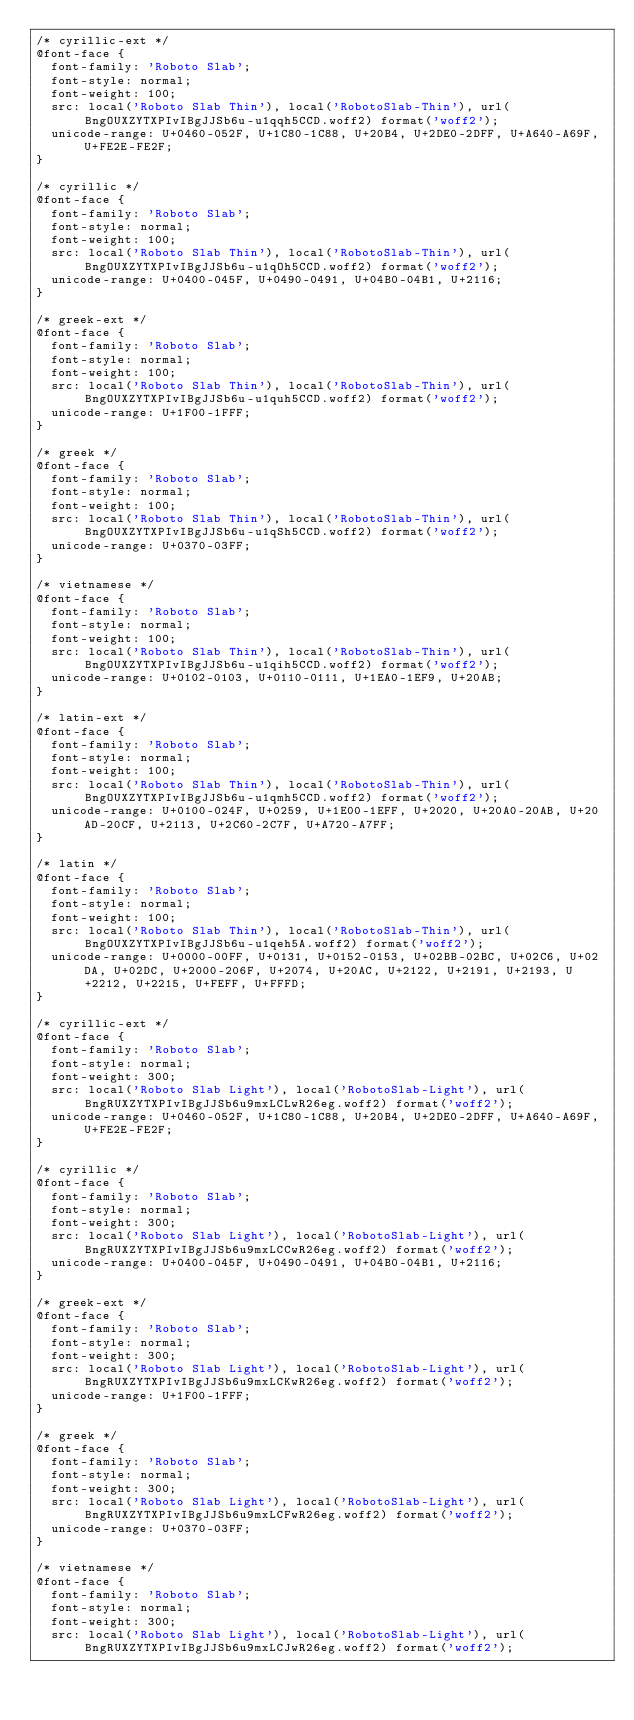Convert code to text. <code><loc_0><loc_0><loc_500><loc_500><_CSS_>/* cyrillic-ext */
@font-face {
	font-family: 'Roboto Slab';
	font-style: normal;
	font-weight: 100;
	src: local('Roboto Slab Thin'), local('RobotoSlab-Thin'), url(BngOUXZYTXPIvIBgJJSb6u-u1qqh5CCD.woff2) format('woff2');
	unicode-range: U+0460-052F, U+1C80-1C88, U+20B4, U+2DE0-2DFF, U+A640-A69F, U+FE2E-FE2F;
}

/* cyrillic */
@font-face {
	font-family: 'Roboto Slab';
	font-style: normal;
	font-weight: 100;
	src: local('Roboto Slab Thin'), local('RobotoSlab-Thin'), url(BngOUXZYTXPIvIBgJJSb6u-u1qOh5CCD.woff2) format('woff2');
	unicode-range: U+0400-045F, U+0490-0491, U+04B0-04B1, U+2116;
}

/* greek-ext */
@font-face {
	font-family: 'Roboto Slab';
	font-style: normal;
	font-weight: 100;
	src: local('Roboto Slab Thin'), local('RobotoSlab-Thin'), url(BngOUXZYTXPIvIBgJJSb6u-u1quh5CCD.woff2) format('woff2');
	unicode-range: U+1F00-1FFF;
}

/* greek */
@font-face {
	font-family: 'Roboto Slab';
	font-style: normal;
	font-weight: 100;
	src: local('Roboto Slab Thin'), local('RobotoSlab-Thin'), url(BngOUXZYTXPIvIBgJJSb6u-u1qSh5CCD.woff2) format('woff2');
	unicode-range: U+0370-03FF;
}

/* vietnamese */
@font-face {
	font-family: 'Roboto Slab';
	font-style: normal;
	font-weight: 100;
	src: local('Roboto Slab Thin'), local('RobotoSlab-Thin'), url(BngOUXZYTXPIvIBgJJSb6u-u1qih5CCD.woff2) format('woff2');
	unicode-range: U+0102-0103, U+0110-0111, U+1EA0-1EF9, U+20AB;
}

/* latin-ext */
@font-face {
	font-family: 'Roboto Slab';
	font-style: normal;
	font-weight: 100;
	src: local('Roboto Slab Thin'), local('RobotoSlab-Thin'), url(BngOUXZYTXPIvIBgJJSb6u-u1qmh5CCD.woff2) format('woff2');
	unicode-range: U+0100-024F, U+0259, U+1E00-1EFF, U+2020, U+20A0-20AB, U+20AD-20CF, U+2113, U+2C60-2C7F, U+A720-A7FF;
}

/* latin */
@font-face {
	font-family: 'Roboto Slab';
	font-style: normal;
	font-weight: 100;
	src: local('Roboto Slab Thin'), local('RobotoSlab-Thin'), url(BngOUXZYTXPIvIBgJJSb6u-u1qeh5A.woff2) format('woff2');
	unicode-range: U+0000-00FF, U+0131, U+0152-0153, U+02BB-02BC, U+02C6, U+02DA, U+02DC, U+2000-206F, U+2074, U+20AC, U+2122, U+2191, U+2193, U+2212, U+2215, U+FEFF, U+FFFD;
}

/* cyrillic-ext */
@font-face {
	font-family: 'Roboto Slab';
	font-style: normal;
	font-weight: 300;
	src: local('Roboto Slab Light'), local('RobotoSlab-Light'), url(BngRUXZYTXPIvIBgJJSb6u9mxLCLwR26eg.woff2) format('woff2');
	unicode-range: U+0460-052F, U+1C80-1C88, U+20B4, U+2DE0-2DFF, U+A640-A69F, U+FE2E-FE2F;
}

/* cyrillic */
@font-face {
	font-family: 'Roboto Slab';
	font-style: normal;
	font-weight: 300;
	src: local('Roboto Slab Light'), local('RobotoSlab-Light'), url(BngRUXZYTXPIvIBgJJSb6u9mxLCCwR26eg.woff2) format('woff2');
	unicode-range: U+0400-045F, U+0490-0491, U+04B0-04B1, U+2116;
}

/* greek-ext */
@font-face {
	font-family: 'Roboto Slab';
	font-style: normal;
	font-weight: 300;
	src: local('Roboto Slab Light'), local('RobotoSlab-Light'), url(BngRUXZYTXPIvIBgJJSb6u9mxLCKwR26eg.woff2) format('woff2');
	unicode-range: U+1F00-1FFF;
}

/* greek */
@font-face {
	font-family: 'Roboto Slab';
	font-style: normal;
	font-weight: 300;
	src: local('Roboto Slab Light'), local('RobotoSlab-Light'), url(BngRUXZYTXPIvIBgJJSb6u9mxLCFwR26eg.woff2) format('woff2');
	unicode-range: U+0370-03FF;
}

/* vietnamese */
@font-face {
	font-family: 'Roboto Slab';
	font-style: normal;
	font-weight: 300;
	src: local('Roboto Slab Light'), local('RobotoSlab-Light'), url(BngRUXZYTXPIvIBgJJSb6u9mxLCJwR26eg.woff2) format('woff2');</code> 